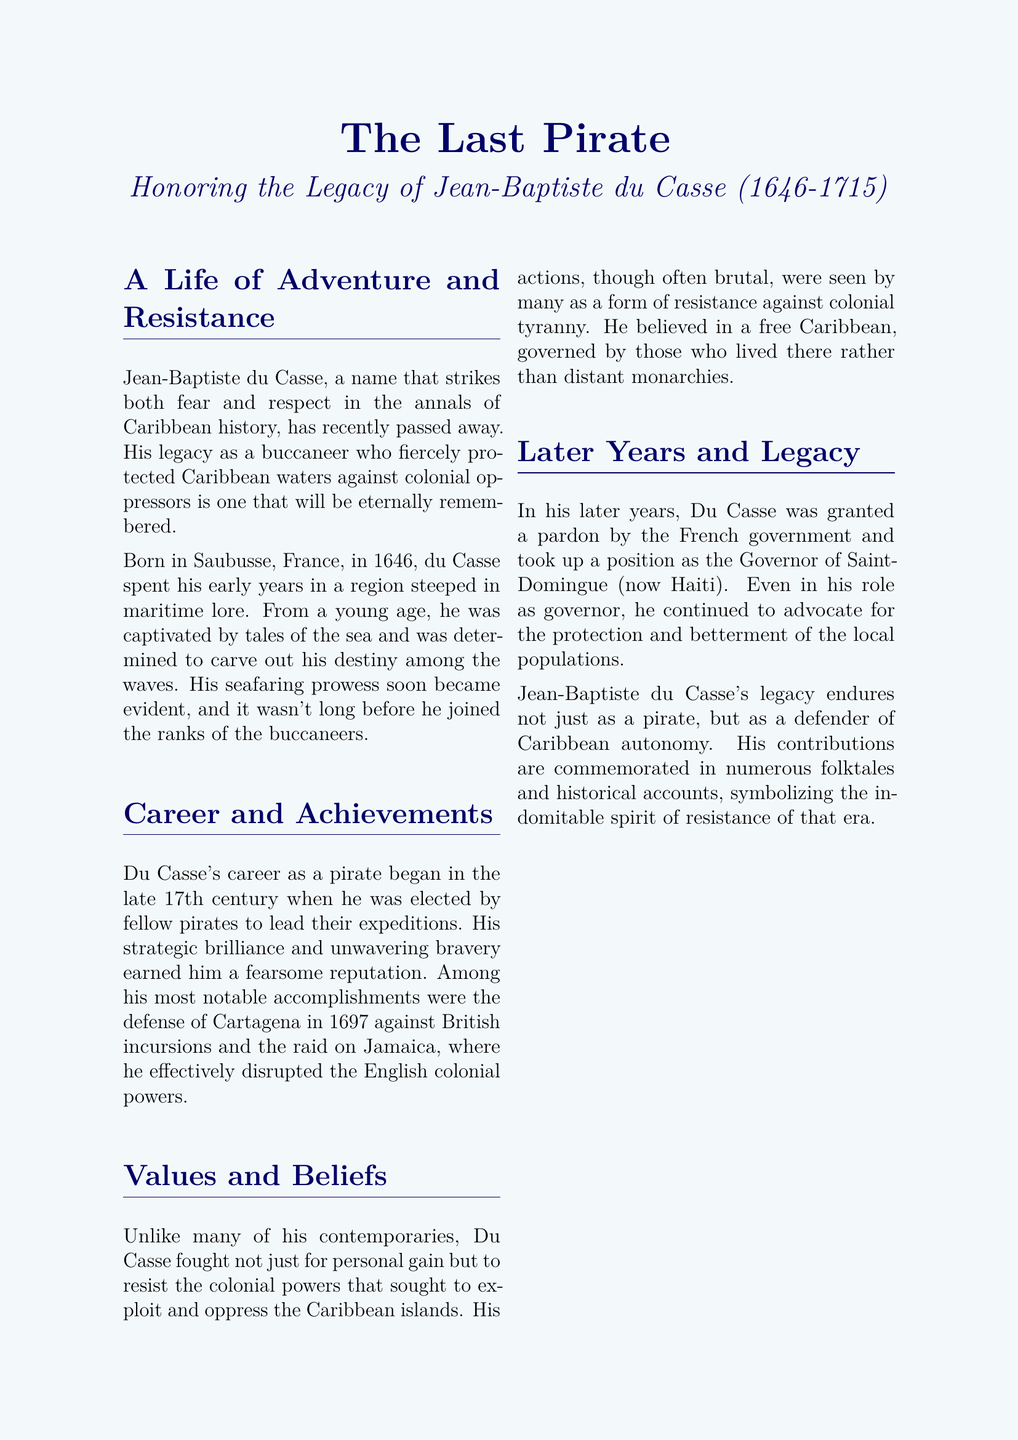What year was Jean-Baptiste du Casse born? The document states that Jean-Baptiste du Casse was born in 1646.
Answer: 1646 Which colonial power did du Casse notably defend against in Cartagena? The document mentions that he defended Cartagena against British incursions.
Answer: British What position did du Casse hold later in his life? According to the document, he became the Governor of Saint-Domingue.
Answer: Governor of Saint-Domingue What was du Casse's primary motivation for his actions? The document notes that he fought to resist the colonial powers rather than for personal gain.
Answer: Resistance against colonial powers What significant quote is attributed to du Casse in the document? The document includes a quote expressing his belief about the Caribbean not being a pawn of European crowns.
Answer: "The Caribbean will not be a pawn in the games of European crowns." In what year did Jean-Baptiste du Casse pass away? The document states that he passed away in 1715.
Answer: 1715 What was du Casse's reputation in Caribbean history? The document describes him as both feared and respected in Caribbean history.
Answer: Feared and respected How is du Casse's impact on Caribbean history described? The document asserts that his life and exploits have left an indelible mark on Caribbean history.
Answer: Indelible mark on Caribbean history 